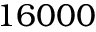<formula> <loc_0><loc_0><loc_500><loc_500>1 6 0 0 0</formula> 